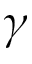Convert formula to latex. <formula><loc_0><loc_0><loc_500><loc_500>\gamma</formula> 